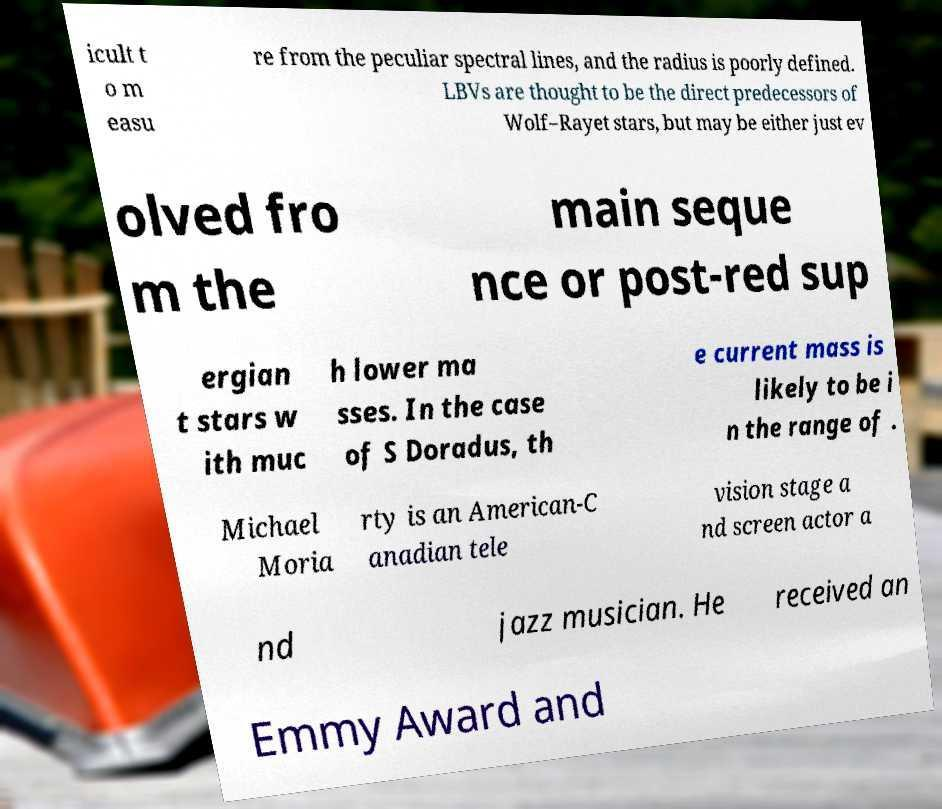Please identify and transcribe the text found in this image. icult t o m easu re from the peculiar spectral lines, and the radius is poorly defined. LBVs are thought to be the direct predecessors of Wolf–Rayet stars, but may be either just ev olved fro m the main seque nce or post-red sup ergian t stars w ith muc h lower ma sses. In the case of S Doradus, th e current mass is likely to be i n the range of . Michael Moria rty is an American-C anadian tele vision stage a nd screen actor a nd jazz musician. He received an Emmy Award and 